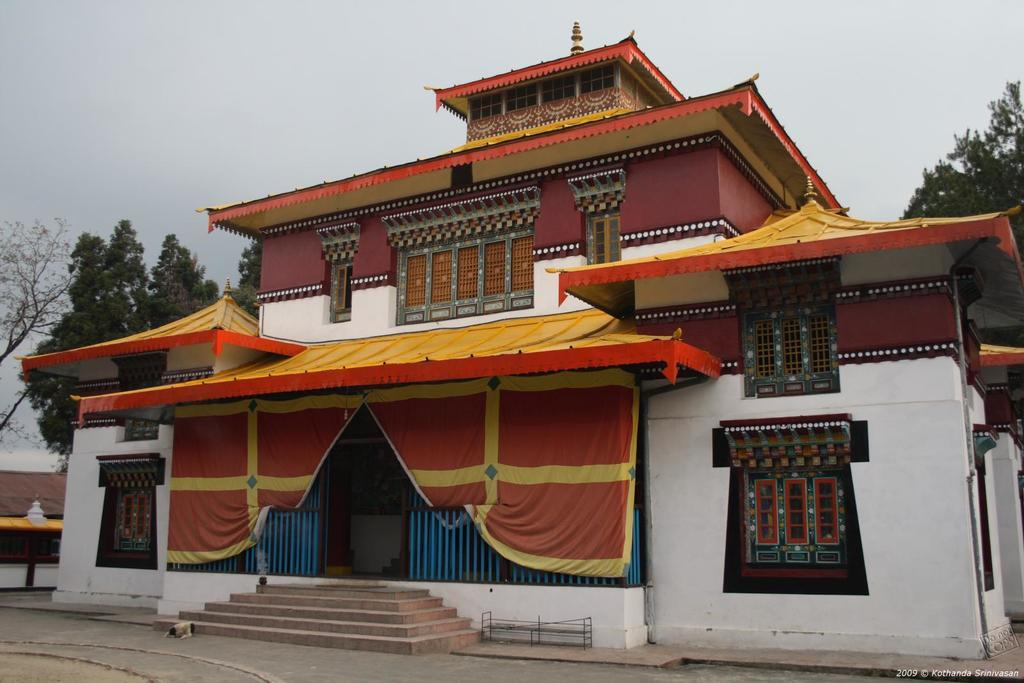What is the main structure in the center of the image? There is a building in the center of the image. What can be seen in the background of the image? There are trees and the sky visible in the background of the image. What is at the bottom of the image? There is a road and stairs at the bottom of the image. How many pairs of shoes can be seen on the stairs in the image? There are no shoes visible in the image; only the building, trees, sky, road, and stairs are present. 